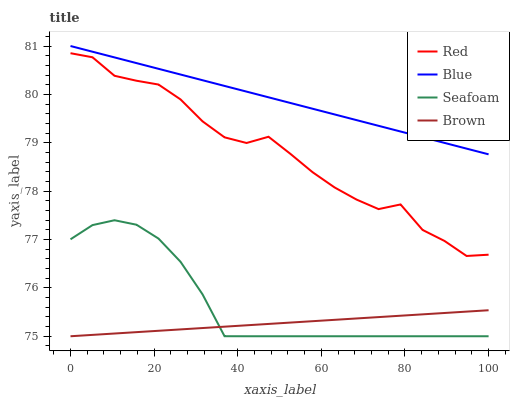Does Brown have the minimum area under the curve?
Answer yes or no. Yes. Does Blue have the maximum area under the curve?
Answer yes or no. Yes. Does Seafoam have the minimum area under the curve?
Answer yes or no. No. Does Seafoam have the maximum area under the curve?
Answer yes or no. No. Is Blue the smoothest?
Answer yes or no. Yes. Is Red the roughest?
Answer yes or no. Yes. Is Brown the smoothest?
Answer yes or no. No. Is Brown the roughest?
Answer yes or no. No. Does Brown have the lowest value?
Answer yes or no. Yes. Does Red have the lowest value?
Answer yes or no. No. Does Blue have the highest value?
Answer yes or no. Yes. Does Seafoam have the highest value?
Answer yes or no. No. Is Brown less than Blue?
Answer yes or no. Yes. Is Red greater than Brown?
Answer yes or no. Yes. Does Brown intersect Seafoam?
Answer yes or no. Yes. Is Brown less than Seafoam?
Answer yes or no. No. Is Brown greater than Seafoam?
Answer yes or no. No. Does Brown intersect Blue?
Answer yes or no. No. 